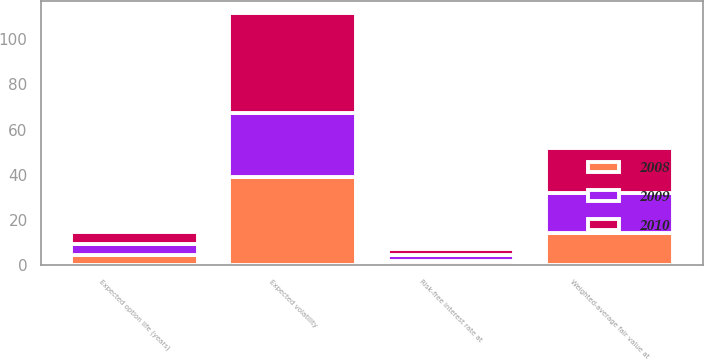Convert chart to OTSL. <chart><loc_0><loc_0><loc_500><loc_500><stacked_bar_chart><ecel><fcel>Weighted-average fair value at<fcel>Expected option life (years)<fcel>Expected volatility<fcel>Risk-free interest rate at<nl><fcel>2010<fcel>19.58<fcel>5.2<fcel>43.8<fcel>2.7<nl><fcel>2008<fcel>14.24<fcel>4.6<fcel>39.2<fcel>1.9<nl><fcel>2009<fcel>17.95<fcel>5.1<fcel>28.2<fcel>2.9<nl></chart> 